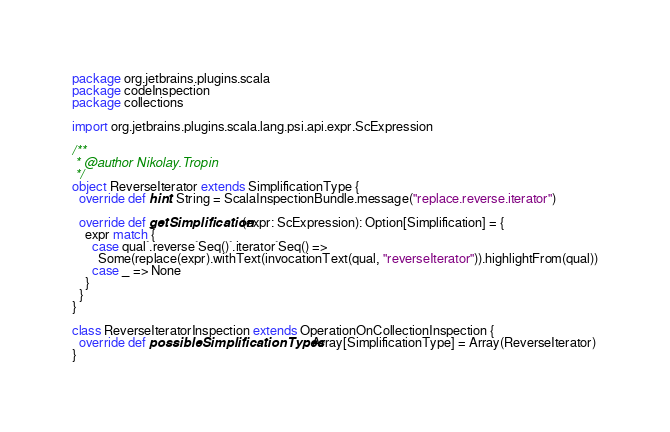<code> <loc_0><loc_0><loc_500><loc_500><_Scala_>package org.jetbrains.plugins.scala
package codeInspection
package collections

import org.jetbrains.plugins.scala.lang.psi.api.expr.ScExpression

/**
 * @author Nikolay.Tropin
 */
object ReverseIterator extends SimplificationType {
  override def hint: String = ScalaInspectionBundle.message("replace.reverse.iterator")

  override def getSimplification(expr: ScExpression): Option[Simplification] = {
    expr match {
      case qual`.reverse`Seq()`.iterator`Seq() =>
        Some(replace(expr).withText(invocationText(qual, "reverseIterator")).highlightFrom(qual))
      case _ => None
    }
  }
}

class ReverseIteratorInspection extends OperationOnCollectionInspection {
  override def possibleSimplificationTypes: Array[SimplificationType] = Array(ReverseIterator)
}
</code> 